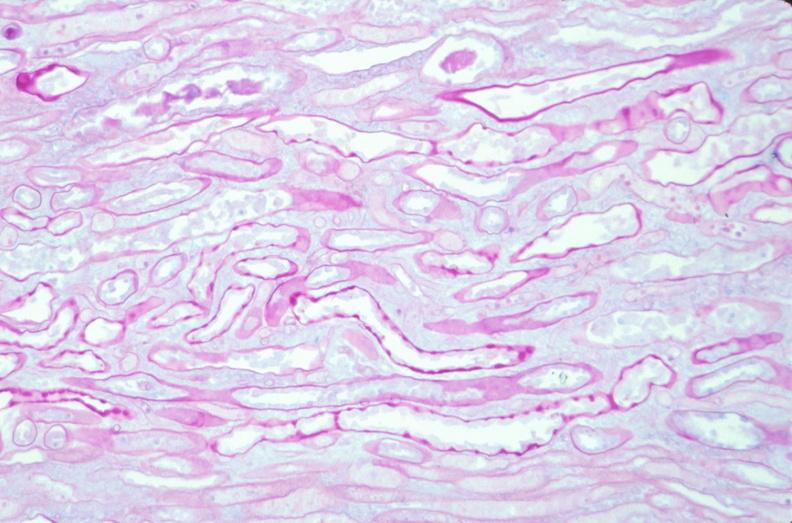why does this image show kidney, thickened and hyalinized basement membranes?
Answer the question using a single word or phrase. Due to diabetes mellitus pas 